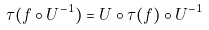<formula> <loc_0><loc_0><loc_500><loc_500>\tau ( f \circ U ^ { - 1 } ) = U \circ \tau ( f ) \circ U ^ { - 1 }</formula> 